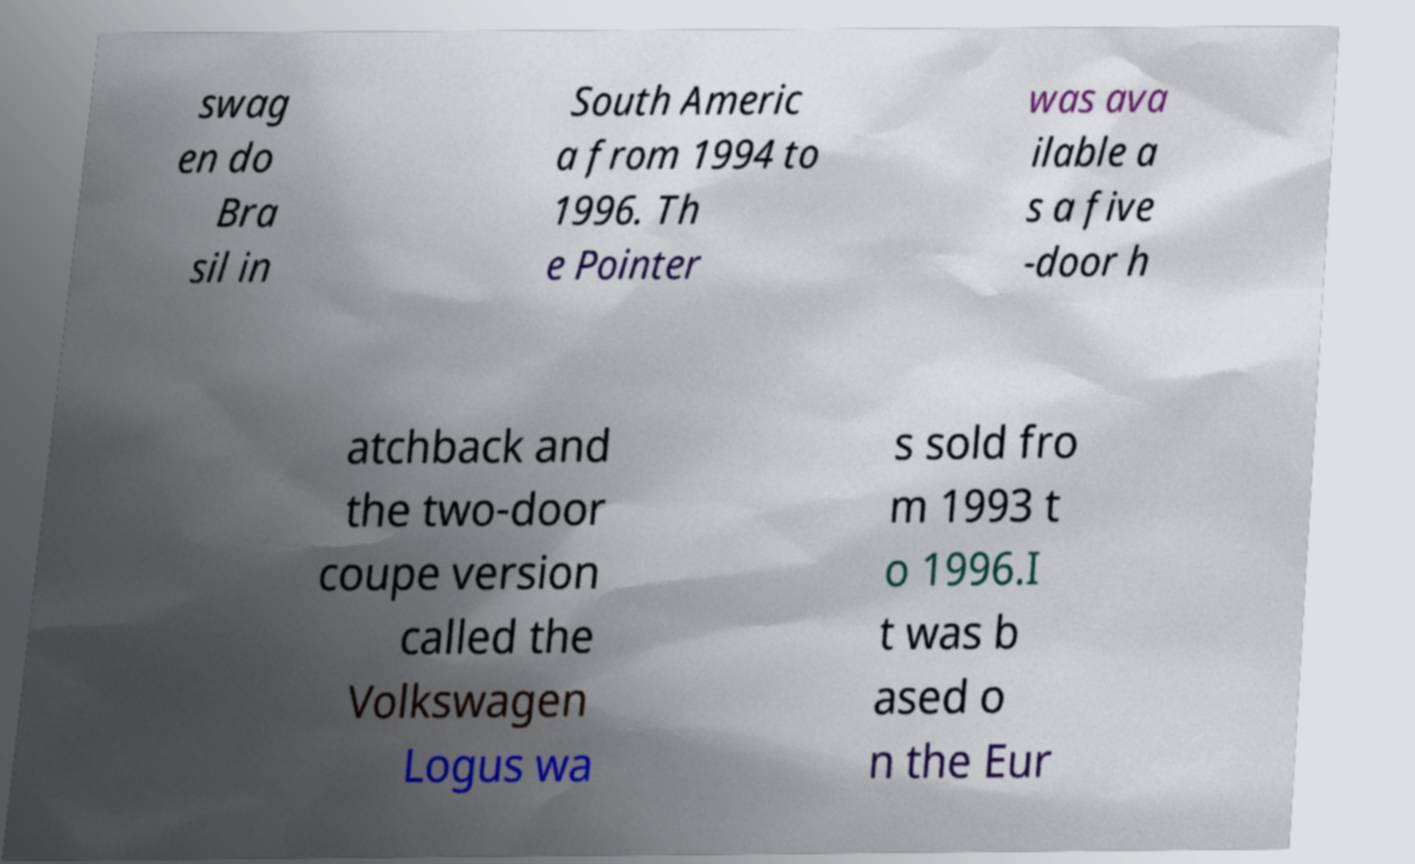Please read and relay the text visible in this image. What does it say? swag en do Bra sil in South Americ a from 1994 to 1996. Th e Pointer was ava ilable a s a five -door h atchback and the two-door coupe version called the Volkswagen Logus wa s sold fro m 1993 t o 1996.I t was b ased o n the Eur 